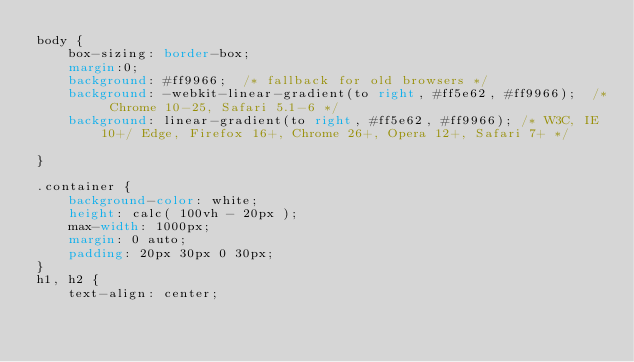<code> <loc_0><loc_0><loc_500><loc_500><_CSS_>body {
    box-sizing: border-box;
    margin:0;
    background: #ff9966;  /* fallback for old browsers */
    background: -webkit-linear-gradient(to right, #ff5e62, #ff9966);  /* Chrome 10-25, Safari 5.1-6 */
    background: linear-gradient(to right, #ff5e62, #ff9966); /* W3C, IE 10+/ Edge, Firefox 16+, Chrome 26+, Opera 12+, Safari 7+ */

}

.container {
    background-color: white;
    height: calc( 100vh - 20px );
    max-width: 1000px;
    margin: 0 auto;
    padding: 20px 30px 0 30px;
}
h1, h2 {
    text-align: center;</code> 